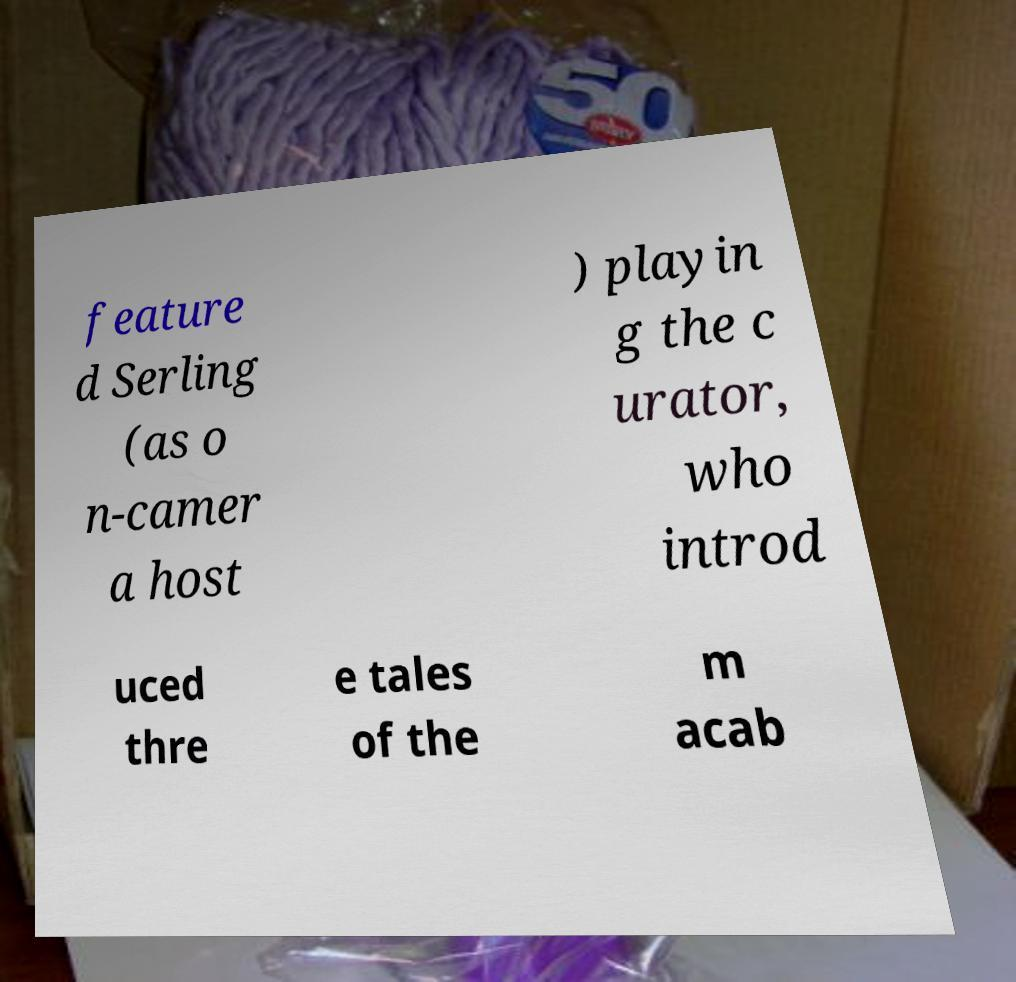Please identify and transcribe the text found in this image. feature d Serling (as o n-camer a host ) playin g the c urator, who introd uced thre e tales of the m acab 